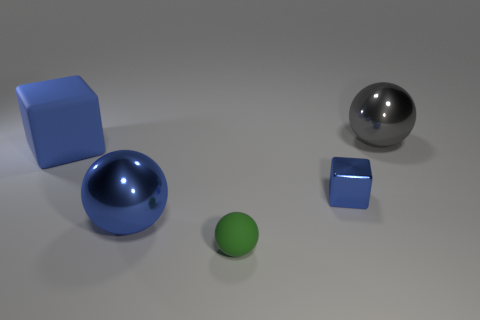What is the color of the large ball that is in front of the big blue matte cube that is behind the tiny green matte sphere?
Keep it short and to the point. Blue. There is a big metal object that is to the left of the big metallic thing on the right side of the big metallic object that is in front of the rubber cube; what shape is it?
Make the answer very short. Sphere. What size is the thing that is left of the tiny green sphere and in front of the tiny metallic block?
Offer a very short reply. Large. What number of big shiny things are the same color as the large rubber block?
Keep it short and to the point. 1. There is a big block that is the same color as the tiny metallic cube; what is its material?
Make the answer very short. Rubber. What material is the small green sphere?
Provide a succinct answer. Rubber. Are the large blue thing in front of the big matte object and the green object made of the same material?
Your response must be concise. No. There is a blue object that is right of the green sphere; what shape is it?
Make the answer very short. Cube. There is a green thing that is the same size as the shiny cube; what material is it?
Provide a short and direct response. Rubber. How many things are metal cubes in front of the big blue block or big things on the left side of the green thing?
Provide a short and direct response. 3. 